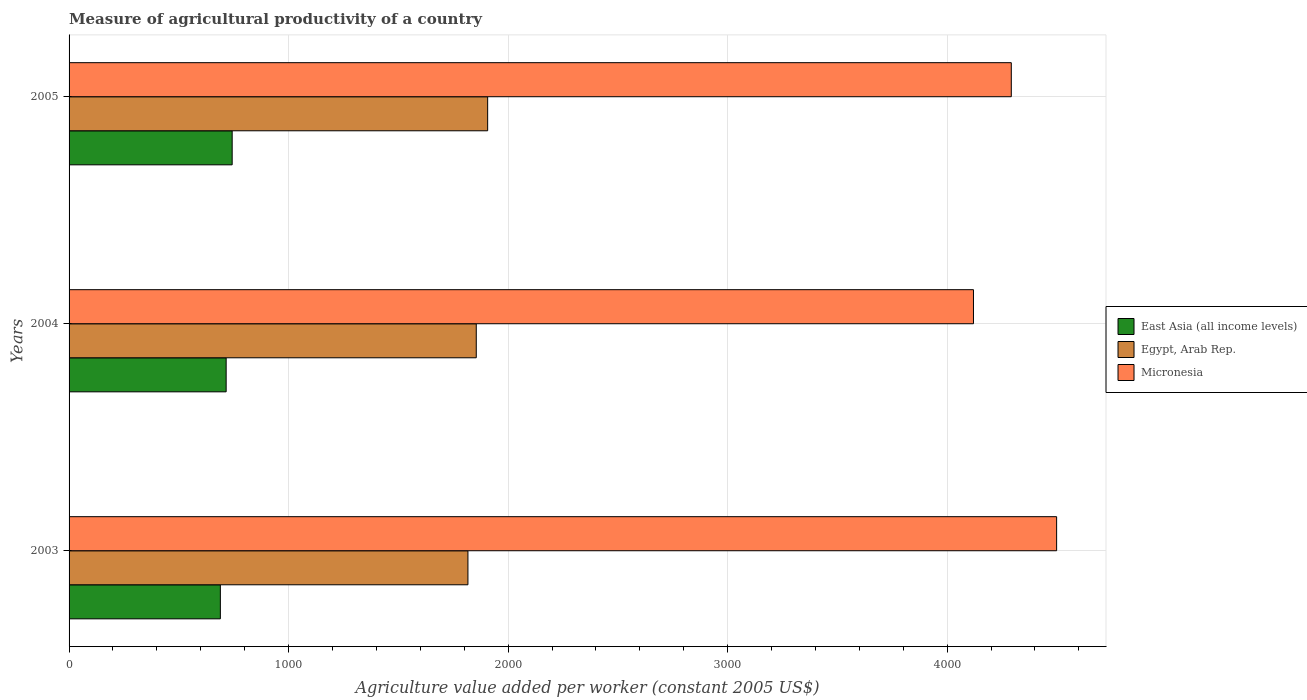How many different coloured bars are there?
Offer a terse response. 3. How many groups of bars are there?
Your answer should be very brief. 3. Are the number of bars per tick equal to the number of legend labels?
Your answer should be very brief. Yes. How many bars are there on the 2nd tick from the top?
Offer a terse response. 3. How many bars are there on the 2nd tick from the bottom?
Your answer should be compact. 3. In how many cases, is the number of bars for a given year not equal to the number of legend labels?
Offer a very short reply. 0. What is the measure of agricultural productivity in Micronesia in 2003?
Offer a terse response. 4498.79. Across all years, what is the maximum measure of agricultural productivity in Egypt, Arab Rep.?
Offer a terse response. 1906.89. Across all years, what is the minimum measure of agricultural productivity in Micronesia?
Ensure brevity in your answer.  4119.99. In which year was the measure of agricultural productivity in Egypt, Arab Rep. minimum?
Offer a terse response. 2003. What is the total measure of agricultural productivity in East Asia (all income levels) in the graph?
Provide a short and direct response. 2147.77. What is the difference between the measure of agricultural productivity in Egypt, Arab Rep. in 2004 and that in 2005?
Your answer should be very brief. -51.95. What is the difference between the measure of agricultural productivity in East Asia (all income levels) in 2004 and the measure of agricultural productivity in Micronesia in 2005?
Keep it short and to the point. -3576.72. What is the average measure of agricultural productivity in East Asia (all income levels) per year?
Ensure brevity in your answer.  715.92. In the year 2005, what is the difference between the measure of agricultural productivity in Egypt, Arab Rep. and measure of agricultural productivity in East Asia (all income levels)?
Offer a terse response. 1163.88. What is the ratio of the measure of agricultural productivity in East Asia (all income levels) in 2003 to that in 2005?
Provide a succinct answer. 0.93. Is the difference between the measure of agricultural productivity in Egypt, Arab Rep. in 2003 and 2004 greater than the difference between the measure of agricultural productivity in East Asia (all income levels) in 2003 and 2004?
Your answer should be very brief. No. What is the difference between the highest and the second highest measure of agricultural productivity in Micronesia?
Keep it short and to the point. 206.49. What is the difference between the highest and the lowest measure of agricultural productivity in Micronesia?
Offer a very short reply. 378.8. In how many years, is the measure of agricultural productivity in Micronesia greater than the average measure of agricultural productivity in Micronesia taken over all years?
Provide a short and direct response. 1. What does the 3rd bar from the top in 2005 represents?
Offer a terse response. East Asia (all income levels). What does the 3rd bar from the bottom in 2005 represents?
Keep it short and to the point. Micronesia. How many years are there in the graph?
Provide a short and direct response. 3. Does the graph contain any zero values?
Your response must be concise. No. What is the title of the graph?
Give a very brief answer. Measure of agricultural productivity of a country. What is the label or title of the X-axis?
Your response must be concise. Agriculture value added per worker (constant 2005 US$). What is the Agriculture value added per worker (constant 2005 US$) of East Asia (all income levels) in 2003?
Give a very brief answer. 689.18. What is the Agriculture value added per worker (constant 2005 US$) of Egypt, Arab Rep. in 2003?
Make the answer very short. 1817.06. What is the Agriculture value added per worker (constant 2005 US$) in Micronesia in 2003?
Give a very brief answer. 4498.79. What is the Agriculture value added per worker (constant 2005 US$) of East Asia (all income levels) in 2004?
Offer a terse response. 715.59. What is the Agriculture value added per worker (constant 2005 US$) of Egypt, Arab Rep. in 2004?
Offer a terse response. 1854.93. What is the Agriculture value added per worker (constant 2005 US$) of Micronesia in 2004?
Offer a terse response. 4119.99. What is the Agriculture value added per worker (constant 2005 US$) of East Asia (all income levels) in 2005?
Provide a short and direct response. 743.01. What is the Agriculture value added per worker (constant 2005 US$) of Egypt, Arab Rep. in 2005?
Ensure brevity in your answer.  1906.89. What is the Agriculture value added per worker (constant 2005 US$) in Micronesia in 2005?
Ensure brevity in your answer.  4292.31. Across all years, what is the maximum Agriculture value added per worker (constant 2005 US$) in East Asia (all income levels)?
Your answer should be very brief. 743.01. Across all years, what is the maximum Agriculture value added per worker (constant 2005 US$) in Egypt, Arab Rep.?
Provide a succinct answer. 1906.89. Across all years, what is the maximum Agriculture value added per worker (constant 2005 US$) in Micronesia?
Give a very brief answer. 4498.79. Across all years, what is the minimum Agriculture value added per worker (constant 2005 US$) of East Asia (all income levels)?
Give a very brief answer. 689.18. Across all years, what is the minimum Agriculture value added per worker (constant 2005 US$) in Egypt, Arab Rep.?
Your answer should be very brief. 1817.06. Across all years, what is the minimum Agriculture value added per worker (constant 2005 US$) in Micronesia?
Make the answer very short. 4119.99. What is the total Agriculture value added per worker (constant 2005 US$) in East Asia (all income levels) in the graph?
Your answer should be compact. 2147.77. What is the total Agriculture value added per worker (constant 2005 US$) of Egypt, Arab Rep. in the graph?
Make the answer very short. 5578.87. What is the total Agriculture value added per worker (constant 2005 US$) of Micronesia in the graph?
Ensure brevity in your answer.  1.29e+04. What is the difference between the Agriculture value added per worker (constant 2005 US$) in East Asia (all income levels) in 2003 and that in 2004?
Provide a succinct answer. -26.41. What is the difference between the Agriculture value added per worker (constant 2005 US$) of Egypt, Arab Rep. in 2003 and that in 2004?
Provide a succinct answer. -37.88. What is the difference between the Agriculture value added per worker (constant 2005 US$) of Micronesia in 2003 and that in 2004?
Your answer should be compact. 378.8. What is the difference between the Agriculture value added per worker (constant 2005 US$) of East Asia (all income levels) in 2003 and that in 2005?
Give a very brief answer. -53.83. What is the difference between the Agriculture value added per worker (constant 2005 US$) in Egypt, Arab Rep. in 2003 and that in 2005?
Give a very brief answer. -89.83. What is the difference between the Agriculture value added per worker (constant 2005 US$) in Micronesia in 2003 and that in 2005?
Your answer should be very brief. 206.49. What is the difference between the Agriculture value added per worker (constant 2005 US$) in East Asia (all income levels) in 2004 and that in 2005?
Keep it short and to the point. -27.42. What is the difference between the Agriculture value added per worker (constant 2005 US$) of Egypt, Arab Rep. in 2004 and that in 2005?
Offer a very short reply. -51.95. What is the difference between the Agriculture value added per worker (constant 2005 US$) in Micronesia in 2004 and that in 2005?
Make the answer very short. -172.32. What is the difference between the Agriculture value added per worker (constant 2005 US$) in East Asia (all income levels) in 2003 and the Agriculture value added per worker (constant 2005 US$) in Egypt, Arab Rep. in 2004?
Provide a succinct answer. -1165.75. What is the difference between the Agriculture value added per worker (constant 2005 US$) in East Asia (all income levels) in 2003 and the Agriculture value added per worker (constant 2005 US$) in Micronesia in 2004?
Provide a succinct answer. -3430.81. What is the difference between the Agriculture value added per worker (constant 2005 US$) in Egypt, Arab Rep. in 2003 and the Agriculture value added per worker (constant 2005 US$) in Micronesia in 2004?
Keep it short and to the point. -2302.93. What is the difference between the Agriculture value added per worker (constant 2005 US$) in East Asia (all income levels) in 2003 and the Agriculture value added per worker (constant 2005 US$) in Egypt, Arab Rep. in 2005?
Keep it short and to the point. -1217.71. What is the difference between the Agriculture value added per worker (constant 2005 US$) of East Asia (all income levels) in 2003 and the Agriculture value added per worker (constant 2005 US$) of Micronesia in 2005?
Offer a very short reply. -3603.13. What is the difference between the Agriculture value added per worker (constant 2005 US$) in Egypt, Arab Rep. in 2003 and the Agriculture value added per worker (constant 2005 US$) in Micronesia in 2005?
Make the answer very short. -2475.25. What is the difference between the Agriculture value added per worker (constant 2005 US$) of East Asia (all income levels) in 2004 and the Agriculture value added per worker (constant 2005 US$) of Egypt, Arab Rep. in 2005?
Your answer should be compact. -1191.3. What is the difference between the Agriculture value added per worker (constant 2005 US$) of East Asia (all income levels) in 2004 and the Agriculture value added per worker (constant 2005 US$) of Micronesia in 2005?
Give a very brief answer. -3576.72. What is the difference between the Agriculture value added per worker (constant 2005 US$) in Egypt, Arab Rep. in 2004 and the Agriculture value added per worker (constant 2005 US$) in Micronesia in 2005?
Keep it short and to the point. -2437.38. What is the average Agriculture value added per worker (constant 2005 US$) in East Asia (all income levels) per year?
Provide a short and direct response. 715.92. What is the average Agriculture value added per worker (constant 2005 US$) in Egypt, Arab Rep. per year?
Your response must be concise. 1859.62. What is the average Agriculture value added per worker (constant 2005 US$) of Micronesia per year?
Offer a terse response. 4303.7. In the year 2003, what is the difference between the Agriculture value added per worker (constant 2005 US$) of East Asia (all income levels) and Agriculture value added per worker (constant 2005 US$) of Egypt, Arab Rep.?
Your answer should be very brief. -1127.88. In the year 2003, what is the difference between the Agriculture value added per worker (constant 2005 US$) in East Asia (all income levels) and Agriculture value added per worker (constant 2005 US$) in Micronesia?
Give a very brief answer. -3809.61. In the year 2003, what is the difference between the Agriculture value added per worker (constant 2005 US$) in Egypt, Arab Rep. and Agriculture value added per worker (constant 2005 US$) in Micronesia?
Make the answer very short. -2681.74. In the year 2004, what is the difference between the Agriculture value added per worker (constant 2005 US$) in East Asia (all income levels) and Agriculture value added per worker (constant 2005 US$) in Egypt, Arab Rep.?
Provide a short and direct response. -1139.35. In the year 2004, what is the difference between the Agriculture value added per worker (constant 2005 US$) of East Asia (all income levels) and Agriculture value added per worker (constant 2005 US$) of Micronesia?
Provide a short and direct response. -3404.4. In the year 2004, what is the difference between the Agriculture value added per worker (constant 2005 US$) of Egypt, Arab Rep. and Agriculture value added per worker (constant 2005 US$) of Micronesia?
Give a very brief answer. -2265.06. In the year 2005, what is the difference between the Agriculture value added per worker (constant 2005 US$) in East Asia (all income levels) and Agriculture value added per worker (constant 2005 US$) in Egypt, Arab Rep.?
Give a very brief answer. -1163.88. In the year 2005, what is the difference between the Agriculture value added per worker (constant 2005 US$) in East Asia (all income levels) and Agriculture value added per worker (constant 2005 US$) in Micronesia?
Give a very brief answer. -3549.3. In the year 2005, what is the difference between the Agriculture value added per worker (constant 2005 US$) in Egypt, Arab Rep. and Agriculture value added per worker (constant 2005 US$) in Micronesia?
Keep it short and to the point. -2385.42. What is the ratio of the Agriculture value added per worker (constant 2005 US$) in East Asia (all income levels) in 2003 to that in 2004?
Give a very brief answer. 0.96. What is the ratio of the Agriculture value added per worker (constant 2005 US$) of Egypt, Arab Rep. in 2003 to that in 2004?
Provide a succinct answer. 0.98. What is the ratio of the Agriculture value added per worker (constant 2005 US$) in Micronesia in 2003 to that in 2004?
Ensure brevity in your answer.  1.09. What is the ratio of the Agriculture value added per worker (constant 2005 US$) of East Asia (all income levels) in 2003 to that in 2005?
Give a very brief answer. 0.93. What is the ratio of the Agriculture value added per worker (constant 2005 US$) in Egypt, Arab Rep. in 2003 to that in 2005?
Provide a short and direct response. 0.95. What is the ratio of the Agriculture value added per worker (constant 2005 US$) in Micronesia in 2003 to that in 2005?
Your answer should be compact. 1.05. What is the ratio of the Agriculture value added per worker (constant 2005 US$) in East Asia (all income levels) in 2004 to that in 2005?
Ensure brevity in your answer.  0.96. What is the ratio of the Agriculture value added per worker (constant 2005 US$) in Egypt, Arab Rep. in 2004 to that in 2005?
Offer a terse response. 0.97. What is the ratio of the Agriculture value added per worker (constant 2005 US$) of Micronesia in 2004 to that in 2005?
Give a very brief answer. 0.96. What is the difference between the highest and the second highest Agriculture value added per worker (constant 2005 US$) in East Asia (all income levels)?
Make the answer very short. 27.42. What is the difference between the highest and the second highest Agriculture value added per worker (constant 2005 US$) of Egypt, Arab Rep.?
Provide a succinct answer. 51.95. What is the difference between the highest and the second highest Agriculture value added per worker (constant 2005 US$) in Micronesia?
Ensure brevity in your answer.  206.49. What is the difference between the highest and the lowest Agriculture value added per worker (constant 2005 US$) in East Asia (all income levels)?
Make the answer very short. 53.83. What is the difference between the highest and the lowest Agriculture value added per worker (constant 2005 US$) in Egypt, Arab Rep.?
Offer a terse response. 89.83. What is the difference between the highest and the lowest Agriculture value added per worker (constant 2005 US$) of Micronesia?
Give a very brief answer. 378.8. 